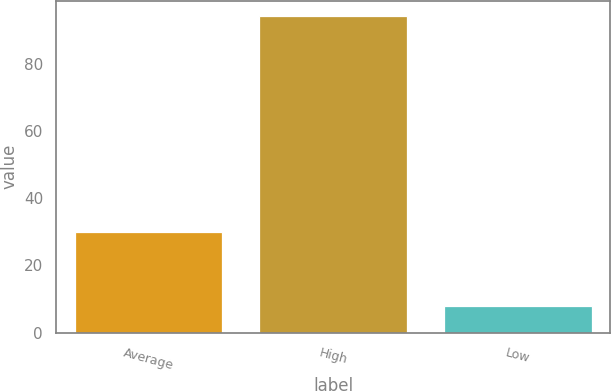Convert chart. <chart><loc_0><loc_0><loc_500><loc_500><bar_chart><fcel>Average<fcel>High<fcel>Low<nl><fcel>30<fcel>94<fcel>8<nl></chart> 